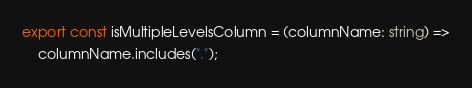<code> <loc_0><loc_0><loc_500><loc_500><_TypeScript_>export const isMultipleLevelsColumn = (columnName: string) =>
	columnName.includes(".");
</code> 